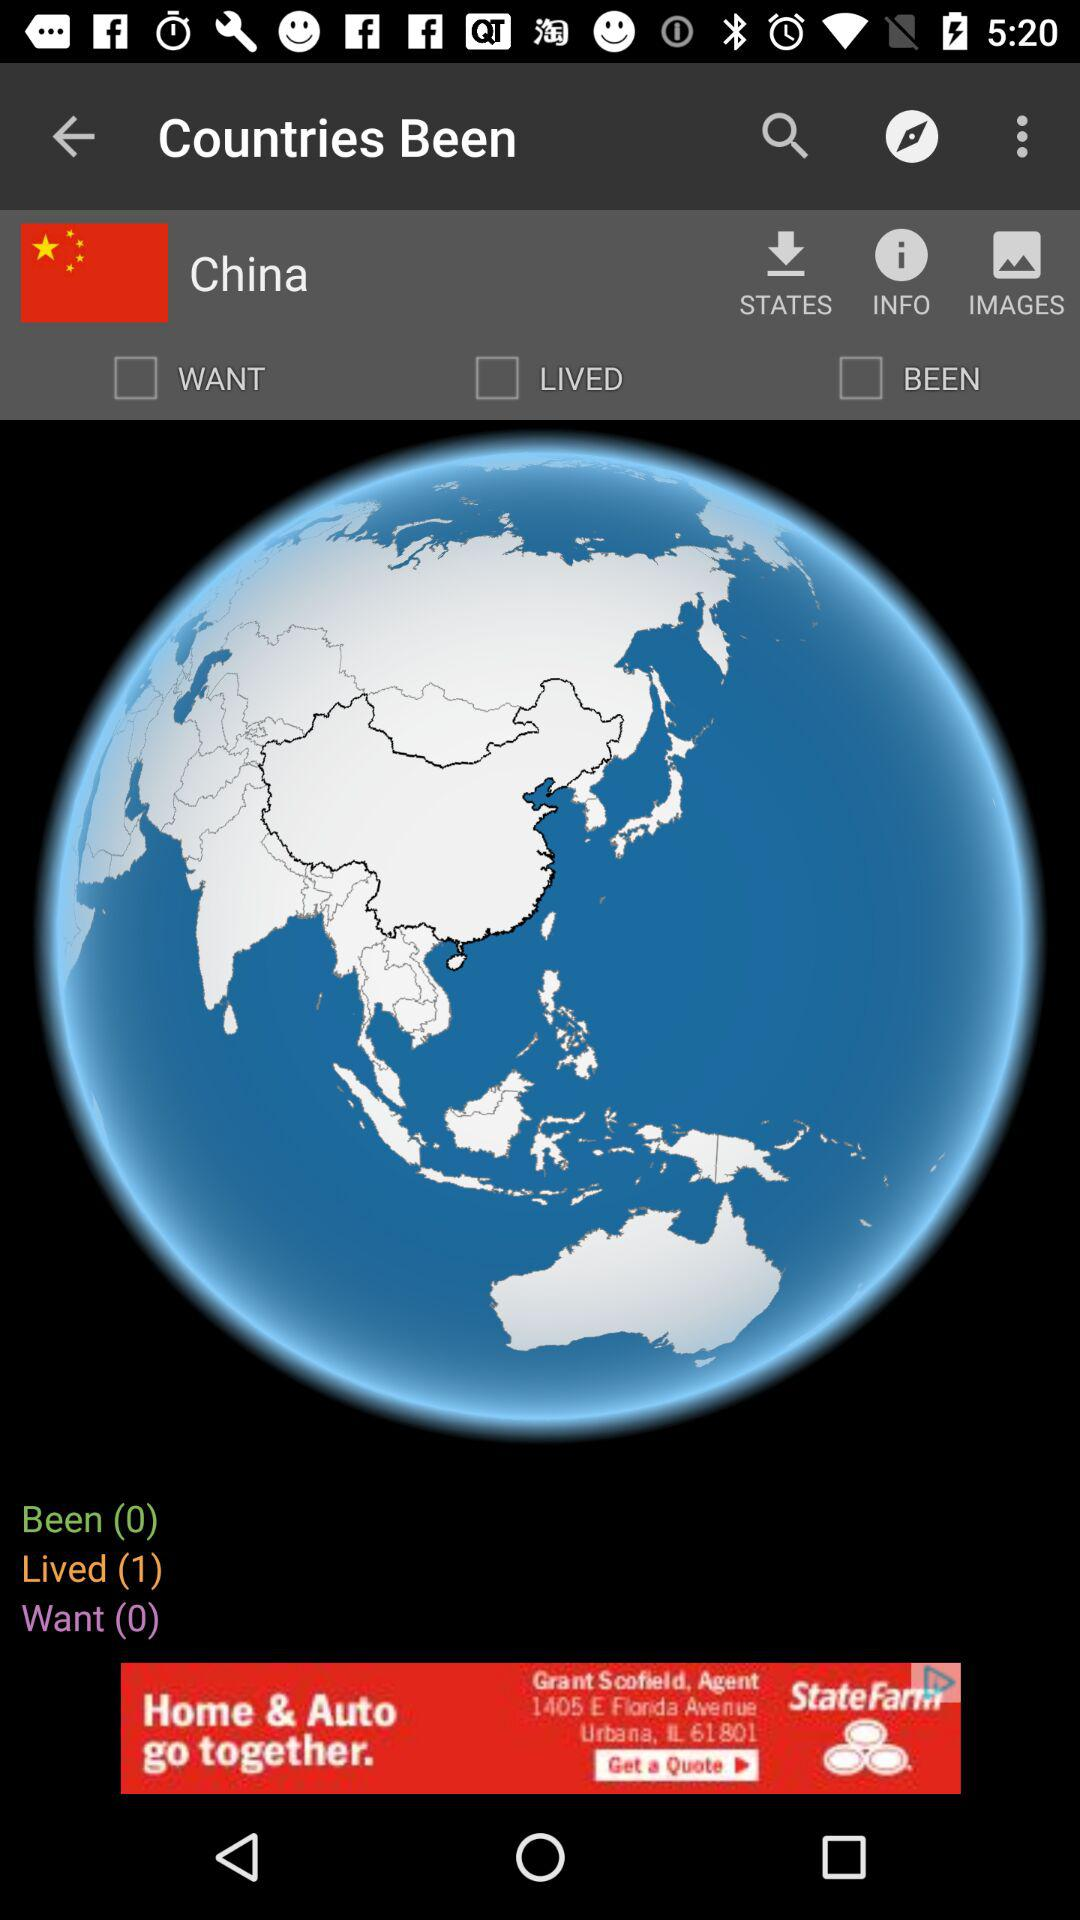How many countries have I lived in?
Answer the question using a single word or phrase. 1 